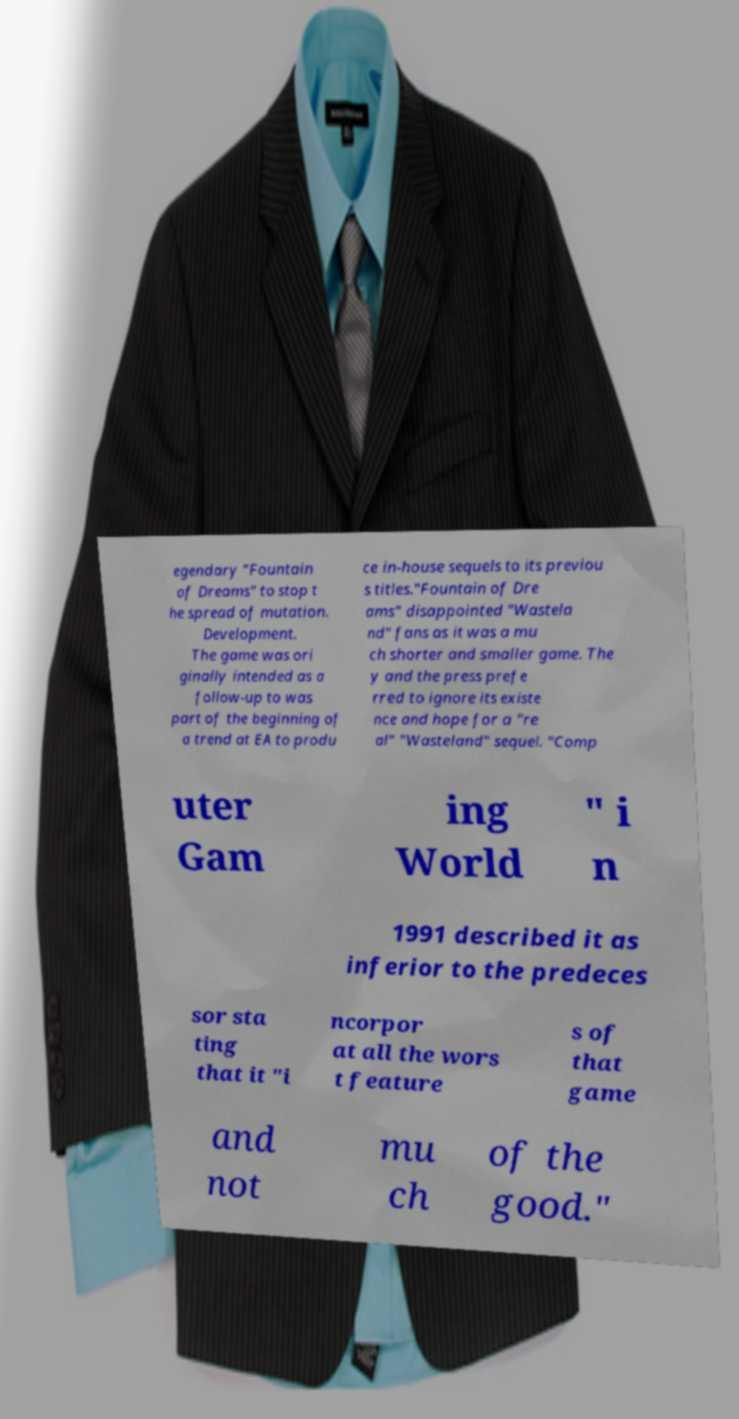Could you extract and type out the text from this image? egendary "Fountain of Dreams" to stop t he spread of mutation. Development. The game was ori ginally intended as a follow-up to was part of the beginning of a trend at EA to produ ce in-house sequels to its previou s titles."Fountain of Dre ams" disappointed "Wastela nd" fans as it was a mu ch shorter and smaller game. The y and the press prefe rred to ignore its existe nce and hope for a "re al" "Wasteland" sequel. "Comp uter Gam ing World " i n 1991 described it as inferior to the predeces sor sta ting that it "i ncorpor at all the wors t feature s of that game and not mu ch of the good." 